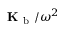<formula> <loc_0><loc_0><loc_500><loc_500>K _ { b } / \omega ^ { 2 }</formula> 